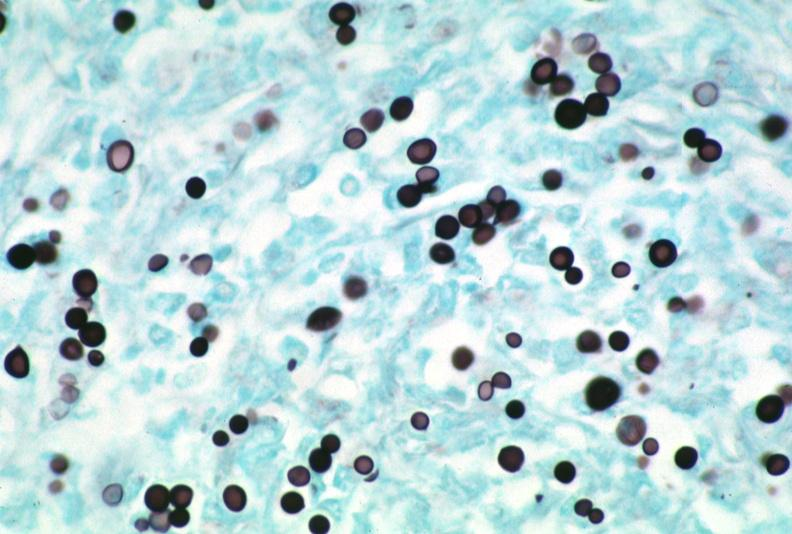what does this image show?
Answer the question using a single word or phrase. Lymph node 